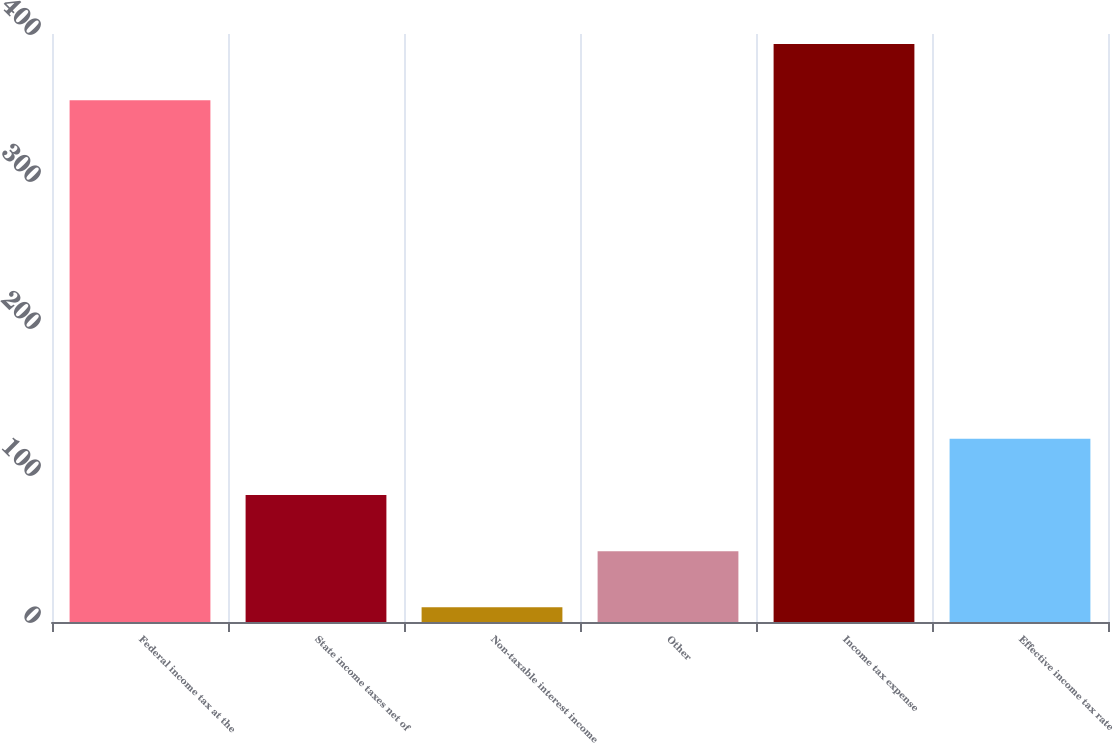<chart> <loc_0><loc_0><loc_500><loc_500><bar_chart><fcel>Federal income tax at the<fcel>State income taxes net of<fcel>Non-taxable interest income<fcel>Other<fcel>Income tax expense<fcel>Effective income tax rate<nl><fcel>355<fcel>86.4<fcel>10<fcel>48.2<fcel>393.2<fcel>124.6<nl></chart> 